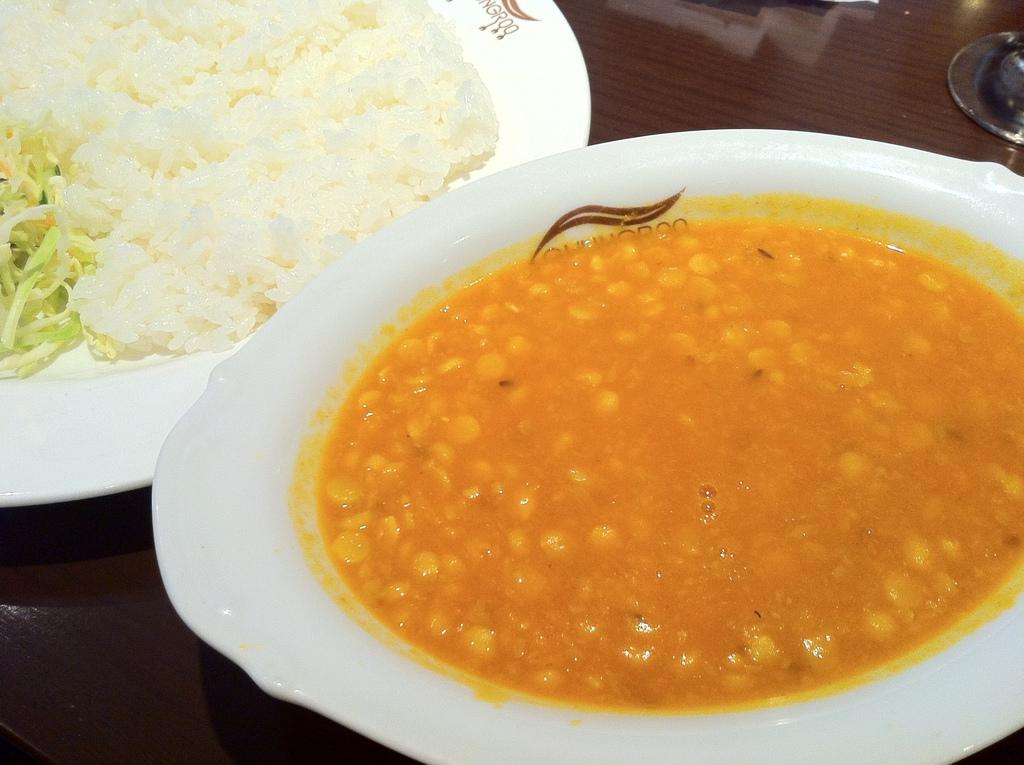What type of food can be seen in the plate and bowl in the image? The food in the plate and bowl has white and orange colors. Where are the plate and bowl located in the image? The plate and bowl are placed on a table. Can you tell me how many times the minister turns on the hose in the image? There is no minister or hose present in the image; it features a plate and bowl with food on a table. 